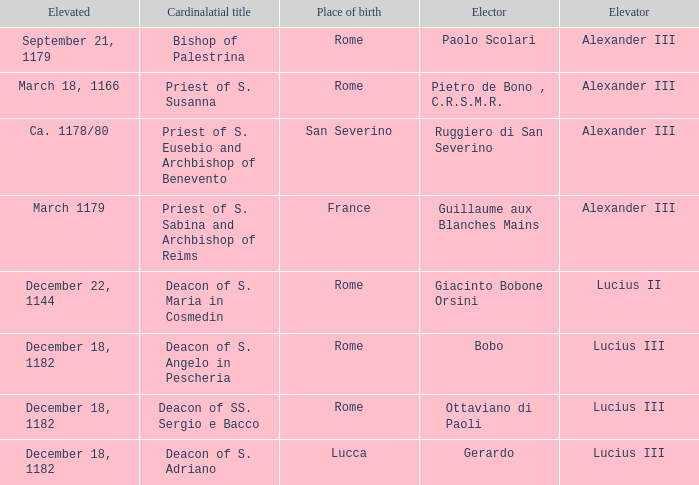Who is the Elector with a Cardinalatial title of Priest of S. Sabina and Archbishop of Reims? Guillaume aux Blanches Mains. 